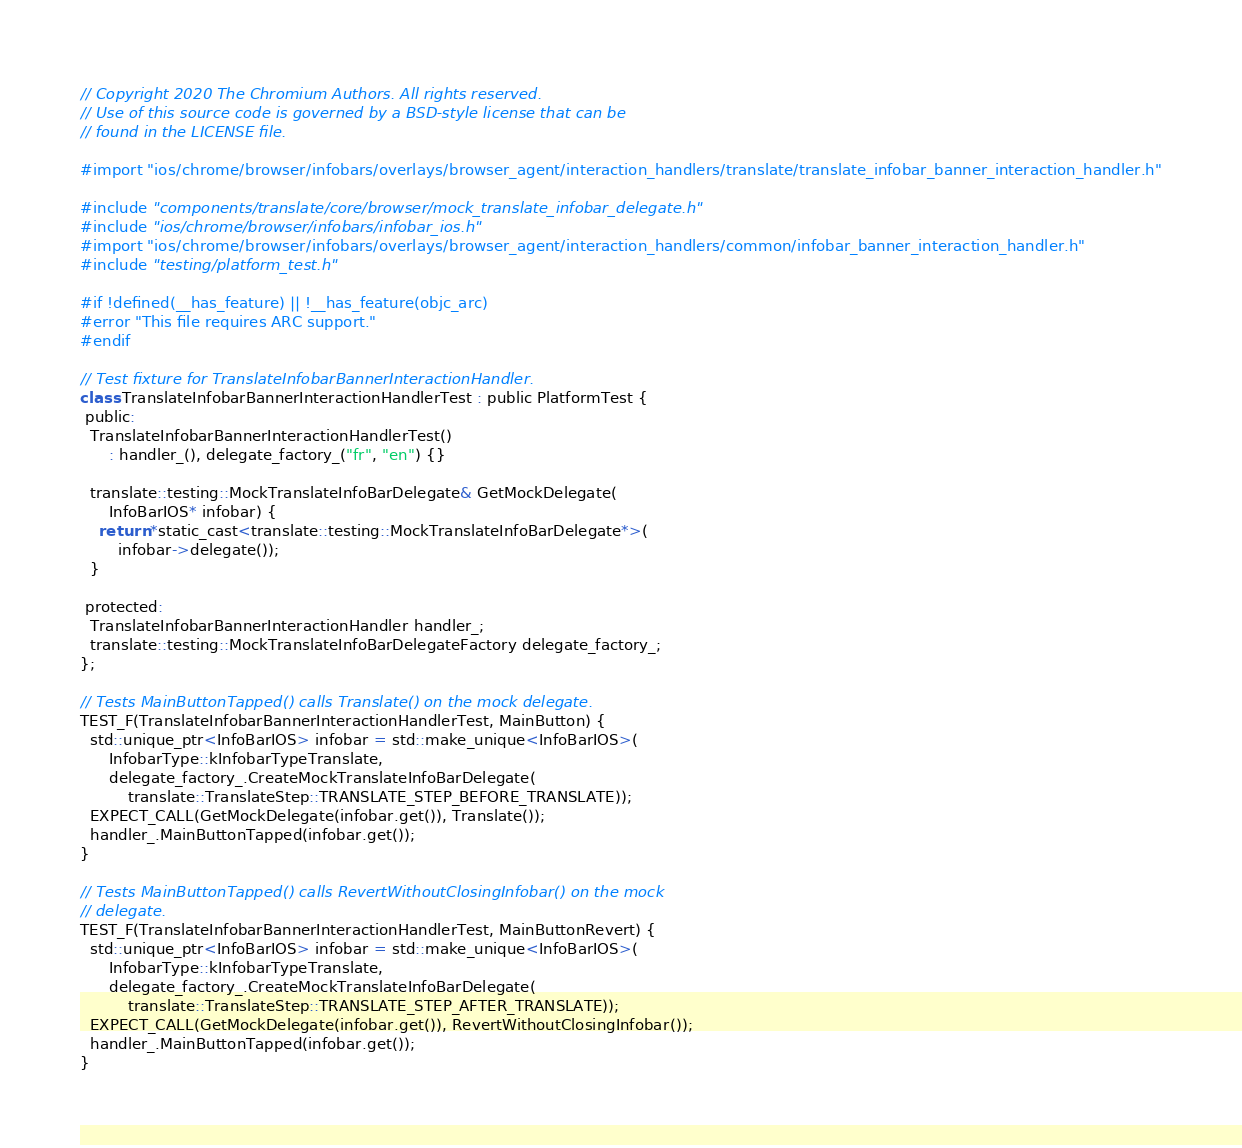<code> <loc_0><loc_0><loc_500><loc_500><_ObjectiveC_>// Copyright 2020 The Chromium Authors. All rights reserved.
// Use of this source code is governed by a BSD-style license that can be
// found in the LICENSE file.

#import "ios/chrome/browser/infobars/overlays/browser_agent/interaction_handlers/translate/translate_infobar_banner_interaction_handler.h"

#include "components/translate/core/browser/mock_translate_infobar_delegate.h"
#include "ios/chrome/browser/infobars/infobar_ios.h"
#import "ios/chrome/browser/infobars/overlays/browser_agent/interaction_handlers/common/infobar_banner_interaction_handler.h"
#include "testing/platform_test.h"

#if !defined(__has_feature) || !__has_feature(objc_arc)
#error "This file requires ARC support."
#endif

// Test fixture for TranslateInfobarBannerInteractionHandler.
class TranslateInfobarBannerInteractionHandlerTest : public PlatformTest {
 public:
  TranslateInfobarBannerInteractionHandlerTest()
      : handler_(), delegate_factory_("fr", "en") {}

  translate::testing::MockTranslateInfoBarDelegate& GetMockDelegate(
      InfoBarIOS* infobar) {
    return *static_cast<translate::testing::MockTranslateInfoBarDelegate*>(
        infobar->delegate());
  }

 protected:
  TranslateInfobarBannerInteractionHandler handler_;
  translate::testing::MockTranslateInfoBarDelegateFactory delegate_factory_;
};

// Tests MainButtonTapped() calls Translate() on the mock delegate.
TEST_F(TranslateInfobarBannerInteractionHandlerTest, MainButton) {
  std::unique_ptr<InfoBarIOS> infobar = std::make_unique<InfoBarIOS>(
      InfobarType::kInfobarTypeTranslate,
      delegate_factory_.CreateMockTranslateInfoBarDelegate(
          translate::TranslateStep::TRANSLATE_STEP_BEFORE_TRANSLATE));
  EXPECT_CALL(GetMockDelegate(infobar.get()), Translate());
  handler_.MainButtonTapped(infobar.get());
}

// Tests MainButtonTapped() calls RevertWithoutClosingInfobar() on the mock
// delegate.
TEST_F(TranslateInfobarBannerInteractionHandlerTest, MainButtonRevert) {
  std::unique_ptr<InfoBarIOS> infobar = std::make_unique<InfoBarIOS>(
      InfobarType::kInfobarTypeTranslate,
      delegate_factory_.CreateMockTranslateInfoBarDelegate(
          translate::TranslateStep::TRANSLATE_STEP_AFTER_TRANSLATE));
  EXPECT_CALL(GetMockDelegate(infobar.get()), RevertWithoutClosingInfobar());
  handler_.MainButtonTapped(infobar.get());
}
</code> 